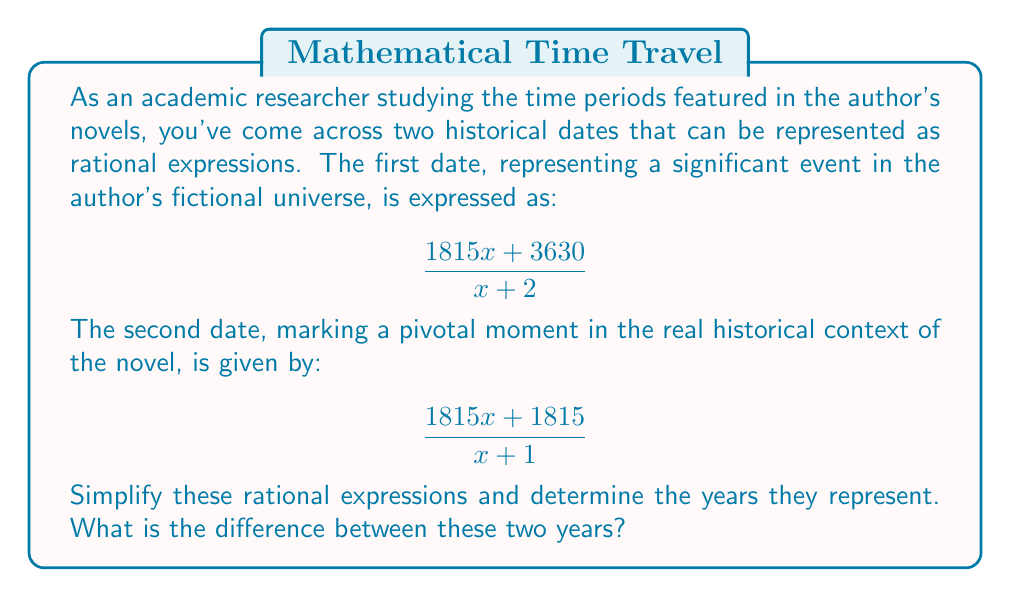Can you solve this math problem? Let's simplify each rational expression step-by-step:

1. For the first expression:
   $$\frac{1815x + 3630}{x + 2}$$
   We can factor out 1815 from the numerator:
   $$\frac{1815(x + 2)}{x + 2}$$
   The $(x + 2)$ cancels out in the numerator and denominator:
   $$1815$$

2. For the second expression:
   $$\frac{1815x + 1815}{x + 1}$$
   We can factor out 1815 from the numerator:
   $$\frac{1815(x + 1)}{x + 1}$$
   The $(x + 1)$ cancels out in the numerator and denominator:
   $$1815$$

Both expressions simplify to 1815, representing the year 1815.

3. To find the difference between these years:
   $1815 - 1815 = 0$

Therefore, there is no difference between the two years represented by these rational expressions.
Answer: 0 years 